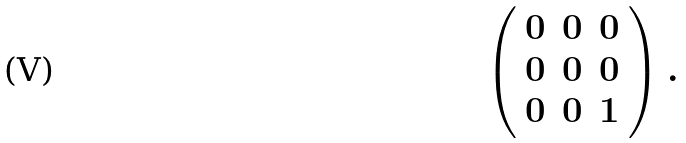Convert formula to latex. <formula><loc_0><loc_0><loc_500><loc_500>\left ( \begin{array} { c c c } { 0 } & { 0 } & { 0 } \\ { 0 } & { 0 } & { 0 } \\ { 0 } & { 0 } & { 1 } \end{array} \right ) .</formula> 